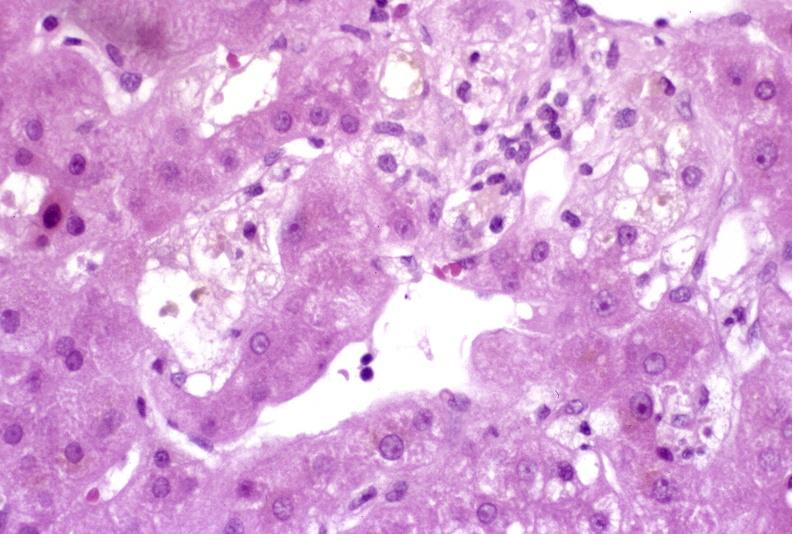does hematologic show recovery of ducts?
Answer the question using a single word or phrase. No 